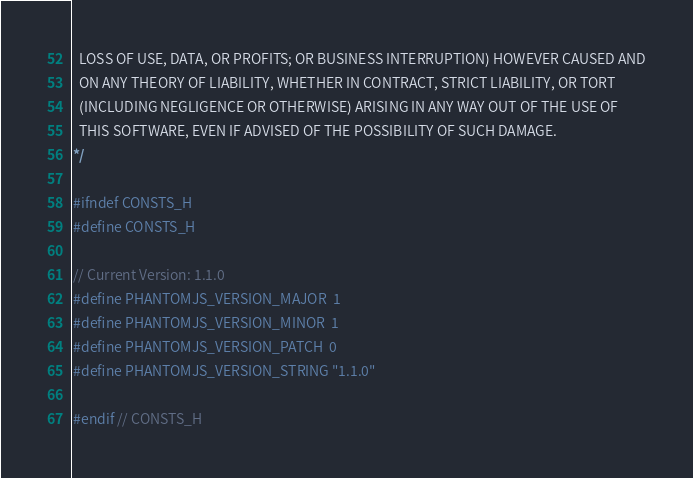Convert code to text. <code><loc_0><loc_0><loc_500><loc_500><_C_>  LOSS OF USE, DATA, OR PROFITS; OR BUSINESS INTERRUPTION) HOWEVER CAUSED AND
  ON ANY THEORY OF LIABILITY, WHETHER IN CONTRACT, STRICT LIABILITY, OR TORT
  (INCLUDING NEGLIGENCE OR OTHERWISE) ARISING IN ANY WAY OUT OF THE USE OF
  THIS SOFTWARE, EVEN IF ADVISED OF THE POSSIBILITY OF SUCH DAMAGE.
*/

#ifndef CONSTS_H
#define CONSTS_H

// Current Version: 1.1.0
#define PHANTOMJS_VERSION_MAJOR  1
#define PHANTOMJS_VERSION_MINOR  1
#define PHANTOMJS_VERSION_PATCH  0
#define PHANTOMJS_VERSION_STRING "1.1.0"

#endif // CONSTS_H
</code> 